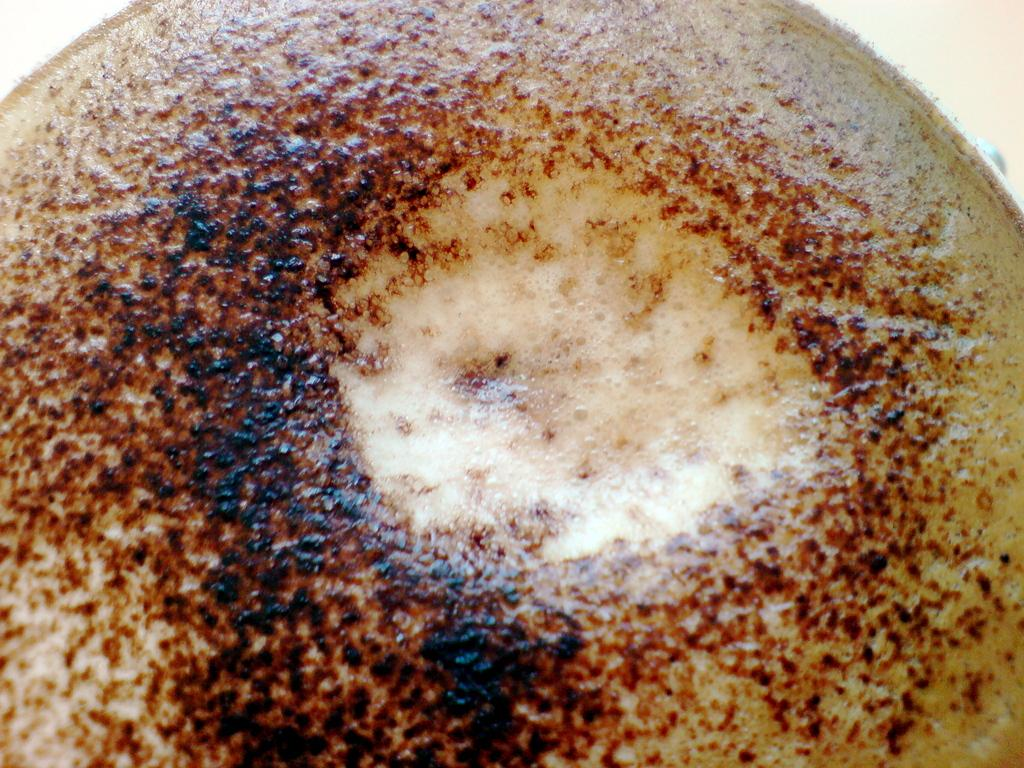What is contained in the object visible in the image? There is coffee in an object (presumably a cup or mug) in the image. Can you see a zebra wearing a mask in the image? No, there is no zebra or mask present in the image. 